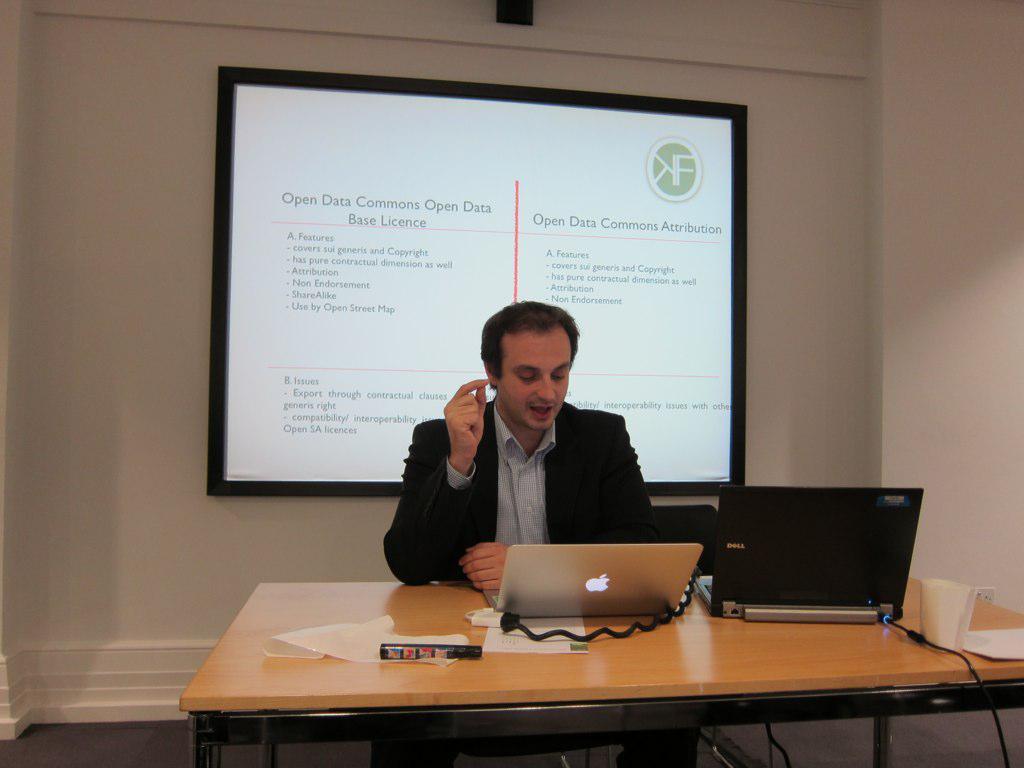Could you give a brief overview of what you see in this image? He is sitting on a chair. There is a table. There are two laptops,glass,paper and sketch on a table. We can see in the background projector and wall. 